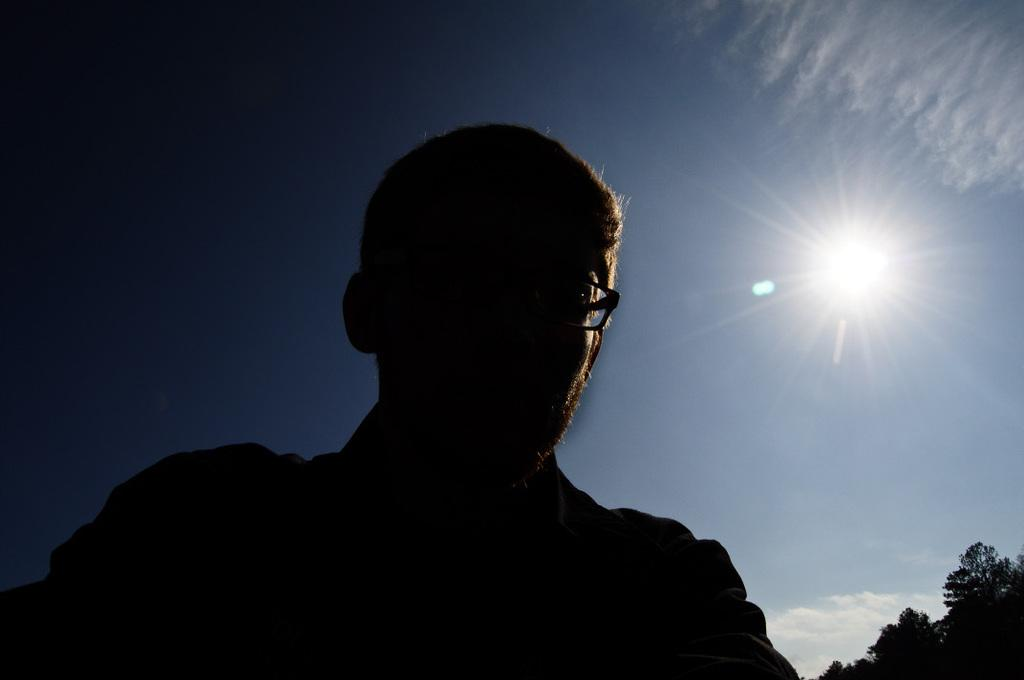Where was the image taken? The image was taken outside. What can be seen in the foreground of the image? There is a man in the foreground of the image. What is visible in the background of the image? The sky, the sun, and trees are visible in the background of the image. What type of lip can be seen on the man in the image? There is no lip visible on the man in the image. Is there any blood visible on the man in the image? There is no blood visible on the man in the image. 